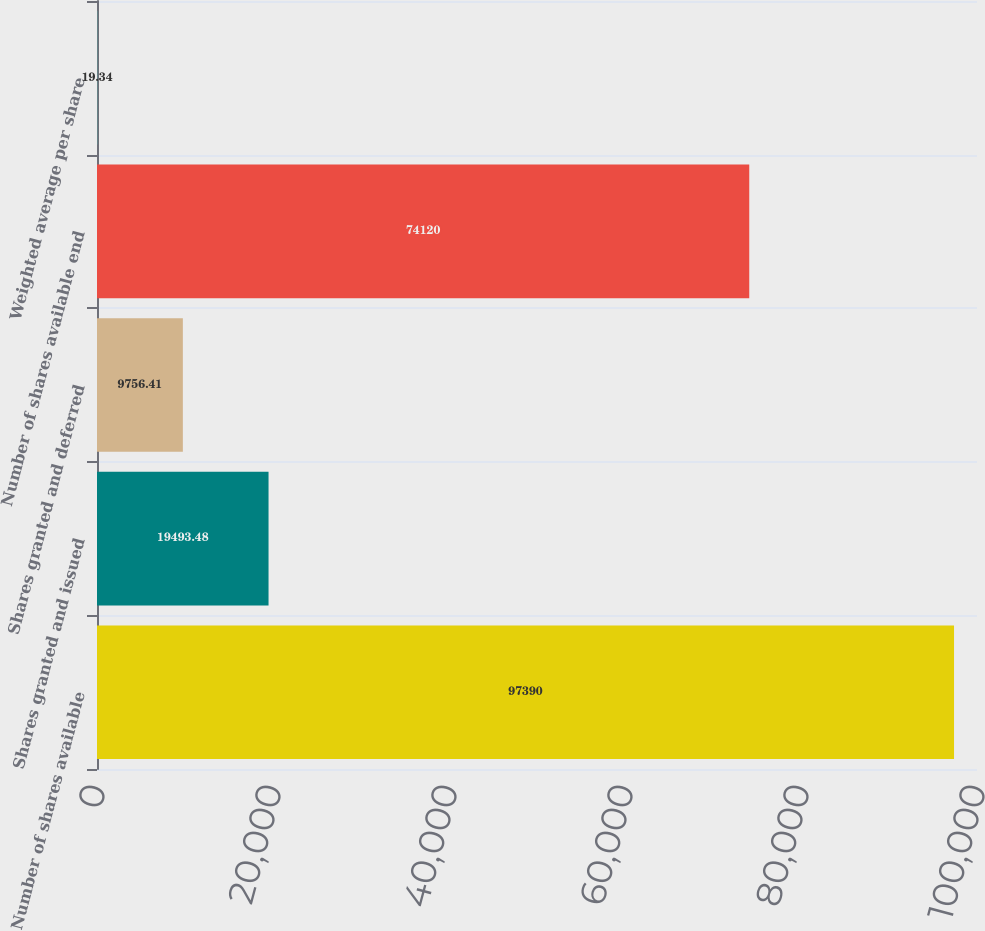Convert chart. <chart><loc_0><loc_0><loc_500><loc_500><bar_chart><fcel>Number of shares available<fcel>Shares granted and issued<fcel>Shares granted and deferred<fcel>Number of shares available end<fcel>Weighted average per share<nl><fcel>97390<fcel>19493.5<fcel>9756.41<fcel>74120<fcel>19.34<nl></chart> 